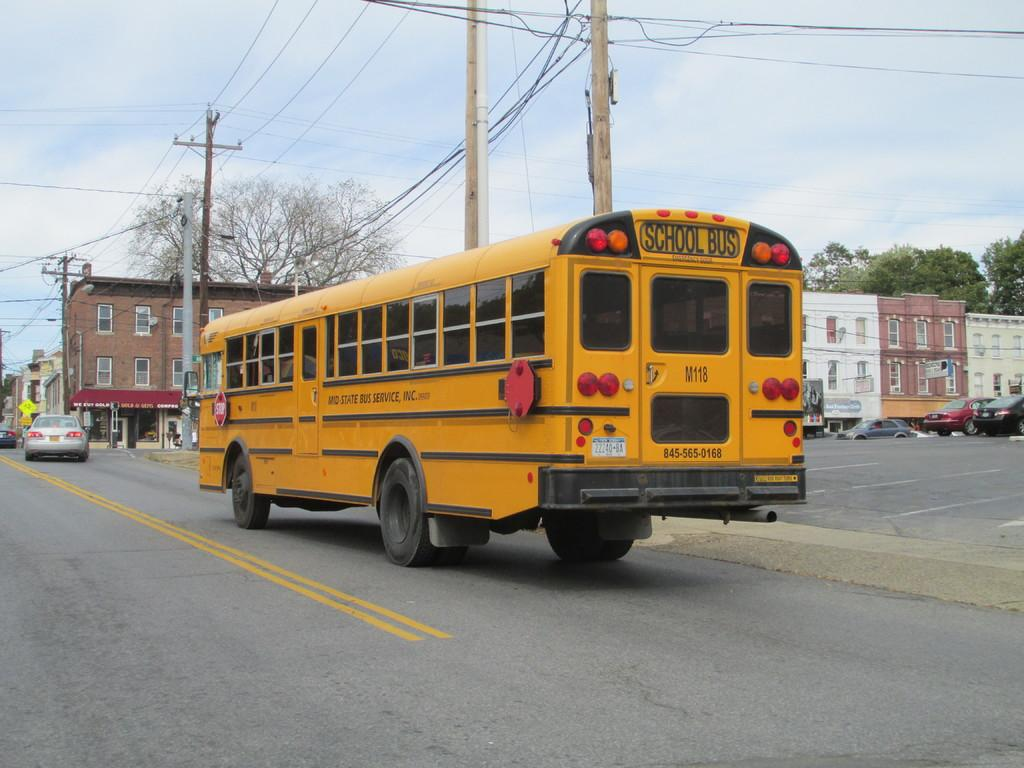What type of vehicle is on the road in the image? There is a bus on the road in the image. What else can be seen in the background of the image? Vehicles, electric poles, wires, buildings, windows, hoardings, and trees are visible in the background. What is the condition of the sky in the image? Clouds are visible in the sky in the image. What type of throat-soothing remedy is visible in the image? There is no throat-soothing remedy present in the image. Can you describe the drainage system in the image? There is no drainage system visible in the image. 